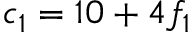<formula> <loc_0><loc_0><loc_500><loc_500>c _ { 1 } = 1 0 + 4 f _ { 1 }</formula> 